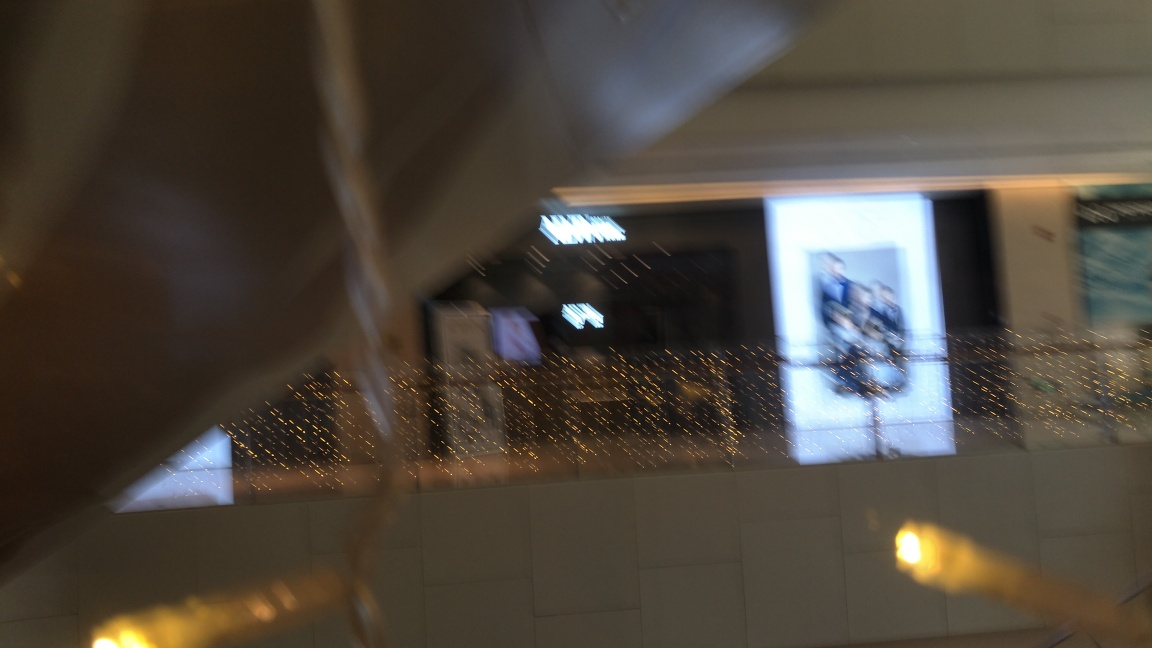What might cause the blurriness in this photo? The blurriness could be due to several factors such as camera shake, a low shutter speed not suitable for the lighting conditions, or an incorrect focus setting. 